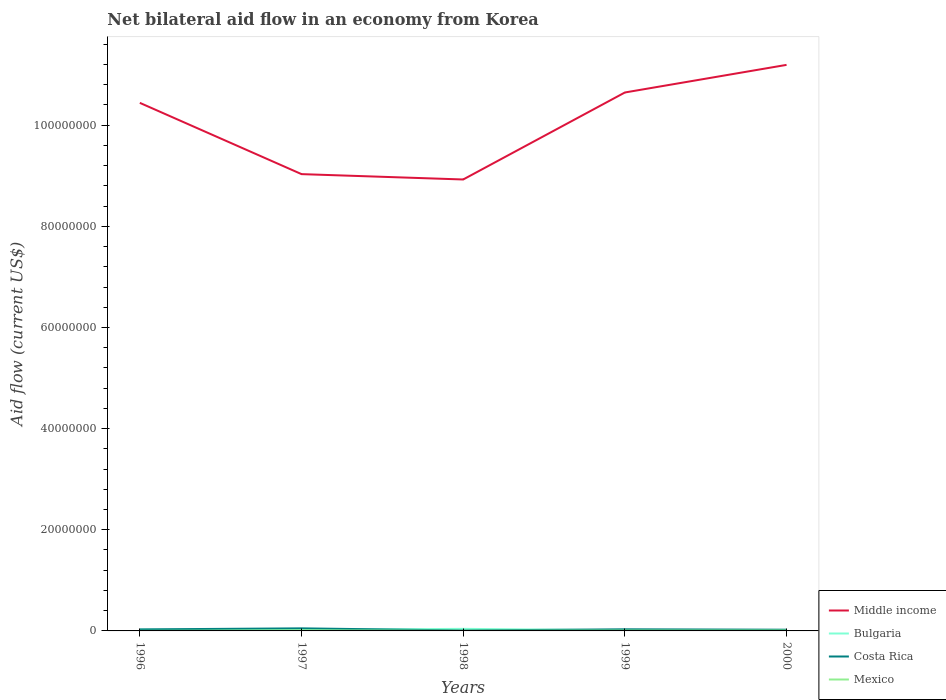How many different coloured lines are there?
Offer a very short reply. 4. Does the line corresponding to Bulgaria intersect with the line corresponding to Mexico?
Offer a terse response. No. Across all years, what is the maximum net bilateral aid flow in Middle income?
Offer a terse response. 8.93e+07. In which year was the net bilateral aid flow in Costa Rica maximum?
Give a very brief answer. 1998. What is the difference between the highest and the second highest net bilateral aid flow in Costa Rica?
Offer a very short reply. 4.20e+05. What is the difference between the highest and the lowest net bilateral aid flow in Bulgaria?
Make the answer very short. 2. Is the net bilateral aid flow in Bulgaria strictly greater than the net bilateral aid flow in Middle income over the years?
Ensure brevity in your answer.  Yes. How many years are there in the graph?
Give a very brief answer. 5. Does the graph contain any zero values?
Your response must be concise. No. How many legend labels are there?
Provide a short and direct response. 4. What is the title of the graph?
Ensure brevity in your answer.  Net bilateral aid flow in an economy from Korea. What is the label or title of the Y-axis?
Give a very brief answer. Aid flow (current US$). What is the Aid flow (current US$) in Middle income in 1996?
Offer a terse response. 1.04e+08. What is the Aid flow (current US$) of Bulgaria in 1996?
Make the answer very short. 2.40e+05. What is the Aid flow (current US$) in Mexico in 1996?
Ensure brevity in your answer.  10000. What is the Aid flow (current US$) of Middle income in 1997?
Your answer should be compact. 9.03e+07. What is the Aid flow (current US$) of Costa Rica in 1997?
Provide a short and direct response. 5.10e+05. What is the Aid flow (current US$) in Middle income in 1998?
Give a very brief answer. 8.93e+07. What is the Aid flow (current US$) of Bulgaria in 1998?
Keep it short and to the point. 4.10e+05. What is the Aid flow (current US$) in Mexico in 1998?
Provide a short and direct response. 3.00e+04. What is the Aid flow (current US$) in Middle income in 1999?
Ensure brevity in your answer.  1.06e+08. What is the Aid flow (current US$) of Bulgaria in 1999?
Offer a terse response. 1.20e+05. What is the Aid flow (current US$) of Mexico in 1999?
Make the answer very short. 7.00e+04. What is the Aid flow (current US$) in Middle income in 2000?
Provide a succinct answer. 1.12e+08. What is the Aid flow (current US$) of Bulgaria in 2000?
Provide a succinct answer. 1.30e+05. What is the Aid flow (current US$) of Costa Rica in 2000?
Offer a very short reply. 2.40e+05. What is the Aid flow (current US$) of Mexico in 2000?
Keep it short and to the point. 8.00e+04. Across all years, what is the maximum Aid flow (current US$) in Middle income?
Ensure brevity in your answer.  1.12e+08. Across all years, what is the maximum Aid flow (current US$) in Bulgaria?
Make the answer very short. 4.10e+05. Across all years, what is the maximum Aid flow (current US$) in Costa Rica?
Ensure brevity in your answer.  5.10e+05. Across all years, what is the maximum Aid flow (current US$) in Mexico?
Offer a very short reply. 1.10e+05. Across all years, what is the minimum Aid flow (current US$) in Middle income?
Make the answer very short. 8.93e+07. Across all years, what is the minimum Aid flow (current US$) in Costa Rica?
Ensure brevity in your answer.  9.00e+04. What is the total Aid flow (current US$) of Middle income in the graph?
Your answer should be very brief. 5.02e+08. What is the total Aid flow (current US$) in Bulgaria in the graph?
Ensure brevity in your answer.  1.10e+06. What is the total Aid flow (current US$) of Costa Rica in the graph?
Offer a very short reply. 1.46e+06. What is the total Aid flow (current US$) of Mexico in the graph?
Your answer should be very brief. 3.00e+05. What is the difference between the Aid flow (current US$) of Middle income in 1996 and that in 1997?
Ensure brevity in your answer.  1.41e+07. What is the difference between the Aid flow (current US$) in Bulgaria in 1996 and that in 1997?
Provide a short and direct response. 4.00e+04. What is the difference between the Aid flow (current US$) in Mexico in 1996 and that in 1997?
Your answer should be compact. -1.00e+05. What is the difference between the Aid flow (current US$) in Middle income in 1996 and that in 1998?
Keep it short and to the point. 1.52e+07. What is the difference between the Aid flow (current US$) in Bulgaria in 1996 and that in 1998?
Provide a succinct answer. -1.70e+05. What is the difference between the Aid flow (current US$) in Costa Rica in 1996 and that in 1998?
Your answer should be compact. 2.10e+05. What is the difference between the Aid flow (current US$) in Mexico in 1996 and that in 1998?
Ensure brevity in your answer.  -2.00e+04. What is the difference between the Aid flow (current US$) of Middle income in 1996 and that in 1999?
Give a very brief answer. -2.05e+06. What is the difference between the Aid flow (current US$) in Bulgaria in 1996 and that in 1999?
Your answer should be compact. 1.20e+05. What is the difference between the Aid flow (current US$) of Costa Rica in 1996 and that in 1999?
Offer a terse response. -2.00e+04. What is the difference between the Aid flow (current US$) in Mexico in 1996 and that in 1999?
Ensure brevity in your answer.  -6.00e+04. What is the difference between the Aid flow (current US$) of Middle income in 1996 and that in 2000?
Offer a very short reply. -7.51e+06. What is the difference between the Aid flow (current US$) of Mexico in 1996 and that in 2000?
Provide a short and direct response. -7.00e+04. What is the difference between the Aid flow (current US$) of Middle income in 1997 and that in 1998?
Provide a succinct answer. 1.06e+06. What is the difference between the Aid flow (current US$) in Bulgaria in 1997 and that in 1998?
Your answer should be very brief. -2.10e+05. What is the difference between the Aid flow (current US$) of Costa Rica in 1997 and that in 1998?
Make the answer very short. 4.20e+05. What is the difference between the Aid flow (current US$) in Mexico in 1997 and that in 1998?
Your response must be concise. 8.00e+04. What is the difference between the Aid flow (current US$) of Middle income in 1997 and that in 1999?
Your response must be concise. -1.61e+07. What is the difference between the Aid flow (current US$) in Bulgaria in 1997 and that in 1999?
Keep it short and to the point. 8.00e+04. What is the difference between the Aid flow (current US$) of Mexico in 1997 and that in 1999?
Keep it short and to the point. 4.00e+04. What is the difference between the Aid flow (current US$) in Middle income in 1997 and that in 2000?
Provide a short and direct response. -2.16e+07. What is the difference between the Aid flow (current US$) of Costa Rica in 1997 and that in 2000?
Provide a short and direct response. 2.70e+05. What is the difference between the Aid flow (current US$) of Middle income in 1998 and that in 1999?
Your answer should be compact. -1.72e+07. What is the difference between the Aid flow (current US$) in Mexico in 1998 and that in 1999?
Provide a short and direct response. -4.00e+04. What is the difference between the Aid flow (current US$) of Middle income in 1998 and that in 2000?
Your answer should be very brief. -2.27e+07. What is the difference between the Aid flow (current US$) in Costa Rica in 1998 and that in 2000?
Offer a terse response. -1.50e+05. What is the difference between the Aid flow (current US$) in Mexico in 1998 and that in 2000?
Offer a terse response. -5.00e+04. What is the difference between the Aid flow (current US$) of Middle income in 1999 and that in 2000?
Offer a terse response. -5.46e+06. What is the difference between the Aid flow (current US$) in Bulgaria in 1999 and that in 2000?
Provide a short and direct response. -10000. What is the difference between the Aid flow (current US$) of Middle income in 1996 and the Aid flow (current US$) of Bulgaria in 1997?
Keep it short and to the point. 1.04e+08. What is the difference between the Aid flow (current US$) of Middle income in 1996 and the Aid flow (current US$) of Costa Rica in 1997?
Offer a very short reply. 1.04e+08. What is the difference between the Aid flow (current US$) of Middle income in 1996 and the Aid flow (current US$) of Mexico in 1997?
Your response must be concise. 1.04e+08. What is the difference between the Aid flow (current US$) of Bulgaria in 1996 and the Aid flow (current US$) of Mexico in 1997?
Your answer should be very brief. 1.30e+05. What is the difference between the Aid flow (current US$) in Middle income in 1996 and the Aid flow (current US$) in Bulgaria in 1998?
Your response must be concise. 1.04e+08. What is the difference between the Aid flow (current US$) in Middle income in 1996 and the Aid flow (current US$) in Costa Rica in 1998?
Your answer should be compact. 1.04e+08. What is the difference between the Aid flow (current US$) of Middle income in 1996 and the Aid flow (current US$) of Mexico in 1998?
Offer a very short reply. 1.04e+08. What is the difference between the Aid flow (current US$) in Bulgaria in 1996 and the Aid flow (current US$) in Costa Rica in 1998?
Make the answer very short. 1.50e+05. What is the difference between the Aid flow (current US$) of Middle income in 1996 and the Aid flow (current US$) of Bulgaria in 1999?
Your answer should be compact. 1.04e+08. What is the difference between the Aid flow (current US$) in Middle income in 1996 and the Aid flow (current US$) in Costa Rica in 1999?
Give a very brief answer. 1.04e+08. What is the difference between the Aid flow (current US$) of Middle income in 1996 and the Aid flow (current US$) of Mexico in 1999?
Provide a succinct answer. 1.04e+08. What is the difference between the Aid flow (current US$) of Bulgaria in 1996 and the Aid flow (current US$) of Costa Rica in 1999?
Offer a very short reply. -8.00e+04. What is the difference between the Aid flow (current US$) of Middle income in 1996 and the Aid flow (current US$) of Bulgaria in 2000?
Give a very brief answer. 1.04e+08. What is the difference between the Aid flow (current US$) of Middle income in 1996 and the Aid flow (current US$) of Costa Rica in 2000?
Your response must be concise. 1.04e+08. What is the difference between the Aid flow (current US$) of Middle income in 1996 and the Aid flow (current US$) of Mexico in 2000?
Your response must be concise. 1.04e+08. What is the difference between the Aid flow (current US$) of Costa Rica in 1996 and the Aid flow (current US$) of Mexico in 2000?
Keep it short and to the point. 2.20e+05. What is the difference between the Aid flow (current US$) in Middle income in 1997 and the Aid flow (current US$) in Bulgaria in 1998?
Ensure brevity in your answer.  8.99e+07. What is the difference between the Aid flow (current US$) in Middle income in 1997 and the Aid flow (current US$) in Costa Rica in 1998?
Your answer should be very brief. 9.02e+07. What is the difference between the Aid flow (current US$) in Middle income in 1997 and the Aid flow (current US$) in Mexico in 1998?
Provide a succinct answer. 9.03e+07. What is the difference between the Aid flow (current US$) of Bulgaria in 1997 and the Aid flow (current US$) of Costa Rica in 1998?
Provide a short and direct response. 1.10e+05. What is the difference between the Aid flow (current US$) in Bulgaria in 1997 and the Aid flow (current US$) in Mexico in 1998?
Provide a succinct answer. 1.70e+05. What is the difference between the Aid flow (current US$) of Costa Rica in 1997 and the Aid flow (current US$) of Mexico in 1998?
Make the answer very short. 4.80e+05. What is the difference between the Aid flow (current US$) in Middle income in 1997 and the Aid flow (current US$) in Bulgaria in 1999?
Provide a short and direct response. 9.02e+07. What is the difference between the Aid flow (current US$) of Middle income in 1997 and the Aid flow (current US$) of Costa Rica in 1999?
Keep it short and to the point. 9.00e+07. What is the difference between the Aid flow (current US$) in Middle income in 1997 and the Aid flow (current US$) in Mexico in 1999?
Keep it short and to the point. 9.02e+07. What is the difference between the Aid flow (current US$) in Costa Rica in 1997 and the Aid flow (current US$) in Mexico in 1999?
Your answer should be very brief. 4.40e+05. What is the difference between the Aid flow (current US$) in Middle income in 1997 and the Aid flow (current US$) in Bulgaria in 2000?
Make the answer very short. 9.02e+07. What is the difference between the Aid flow (current US$) of Middle income in 1997 and the Aid flow (current US$) of Costa Rica in 2000?
Ensure brevity in your answer.  9.01e+07. What is the difference between the Aid flow (current US$) of Middle income in 1997 and the Aid flow (current US$) of Mexico in 2000?
Give a very brief answer. 9.02e+07. What is the difference between the Aid flow (current US$) of Bulgaria in 1997 and the Aid flow (current US$) of Costa Rica in 2000?
Your answer should be very brief. -4.00e+04. What is the difference between the Aid flow (current US$) of Costa Rica in 1997 and the Aid flow (current US$) of Mexico in 2000?
Your response must be concise. 4.30e+05. What is the difference between the Aid flow (current US$) of Middle income in 1998 and the Aid flow (current US$) of Bulgaria in 1999?
Provide a succinct answer. 8.91e+07. What is the difference between the Aid flow (current US$) of Middle income in 1998 and the Aid flow (current US$) of Costa Rica in 1999?
Ensure brevity in your answer.  8.89e+07. What is the difference between the Aid flow (current US$) of Middle income in 1998 and the Aid flow (current US$) of Mexico in 1999?
Offer a very short reply. 8.92e+07. What is the difference between the Aid flow (current US$) in Bulgaria in 1998 and the Aid flow (current US$) in Costa Rica in 1999?
Keep it short and to the point. 9.00e+04. What is the difference between the Aid flow (current US$) of Middle income in 1998 and the Aid flow (current US$) of Bulgaria in 2000?
Keep it short and to the point. 8.91e+07. What is the difference between the Aid flow (current US$) of Middle income in 1998 and the Aid flow (current US$) of Costa Rica in 2000?
Make the answer very short. 8.90e+07. What is the difference between the Aid flow (current US$) in Middle income in 1998 and the Aid flow (current US$) in Mexico in 2000?
Provide a short and direct response. 8.92e+07. What is the difference between the Aid flow (current US$) of Bulgaria in 1998 and the Aid flow (current US$) of Costa Rica in 2000?
Provide a succinct answer. 1.70e+05. What is the difference between the Aid flow (current US$) in Bulgaria in 1998 and the Aid flow (current US$) in Mexico in 2000?
Your answer should be very brief. 3.30e+05. What is the difference between the Aid flow (current US$) in Middle income in 1999 and the Aid flow (current US$) in Bulgaria in 2000?
Give a very brief answer. 1.06e+08. What is the difference between the Aid flow (current US$) in Middle income in 1999 and the Aid flow (current US$) in Costa Rica in 2000?
Ensure brevity in your answer.  1.06e+08. What is the difference between the Aid flow (current US$) in Middle income in 1999 and the Aid flow (current US$) in Mexico in 2000?
Ensure brevity in your answer.  1.06e+08. What is the difference between the Aid flow (current US$) in Bulgaria in 1999 and the Aid flow (current US$) in Costa Rica in 2000?
Provide a short and direct response. -1.20e+05. What is the average Aid flow (current US$) of Middle income per year?
Keep it short and to the point. 1.00e+08. What is the average Aid flow (current US$) in Bulgaria per year?
Give a very brief answer. 2.20e+05. What is the average Aid flow (current US$) of Costa Rica per year?
Keep it short and to the point. 2.92e+05. In the year 1996, what is the difference between the Aid flow (current US$) of Middle income and Aid flow (current US$) of Bulgaria?
Your response must be concise. 1.04e+08. In the year 1996, what is the difference between the Aid flow (current US$) of Middle income and Aid flow (current US$) of Costa Rica?
Provide a short and direct response. 1.04e+08. In the year 1996, what is the difference between the Aid flow (current US$) of Middle income and Aid flow (current US$) of Mexico?
Provide a short and direct response. 1.04e+08. In the year 1997, what is the difference between the Aid flow (current US$) in Middle income and Aid flow (current US$) in Bulgaria?
Ensure brevity in your answer.  9.01e+07. In the year 1997, what is the difference between the Aid flow (current US$) in Middle income and Aid flow (current US$) in Costa Rica?
Offer a terse response. 8.98e+07. In the year 1997, what is the difference between the Aid flow (current US$) in Middle income and Aid flow (current US$) in Mexico?
Make the answer very short. 9.02e+07. In the year 1997, what is the difference between the Aid flow (current US$) in Bulgaria and Aid flow (current US$) in Costa Rica?
Your response must be concise. -3.10e+05. In the year 1998, what is the difference between the Aid flow (current US$) in Middle income and Aid flow (current US$) in Bulgaria?
Provide a succinct answer. 8.88e+07. In the year 1998, what is the difference between the Aid flow (current US$) of Middle income and Aid flow (current US$) of Costa Rica?
Keep it short and to the point. 8.92e+07. In the year 1998, what is the difference between the Aid flow (current US$) of Middle income and Aid flow (current US$) of Mexico?
Give a very brief answer. 8.92e+07. In the year 1998, what is the difference between the Aid flow (current US$) of Bulgaria and Aid flow (current US$) of Costa Rica?
Make the answer very short. 3.20e+05. In the year 1999, what is the difference between the Aid flow (current US$) in Middle income and Aid flow (current US$) in Bulgaria?
Offer a terse response. 1.06e+08. In the year 1999, what is the difference between the Aid flow (current US$) of Middle income and Aid flow (current US$) of Costa Rica?
Keep it short and to the point. 1.06e+08. In the year 1999, what is the difference between the Aid flow (current US$) in Middle income and Aid flow (current US$) in Mexico?
Ensure brevity in your answer.  1.06e+08. In the year 1999, what is the difference between the Aid flow (current US$) of Bulgaria and Aid flow (current US$) of Mexico?
Keep it short and to the point. 5.00e+04. In the year 1999, what is the difference between the Aid flow (current US$) of Costa Rica and Aid flow (current US$) of Mexico?
Provide a short and direct response. 2.50e+05. In the year 2000, what is the difference between the Aid flow (current US$) of Middle income and Aid flow (current US$) of Bulgaria?
Your response must be concise. 1.12e+08. In the year 2000, what is the difference between the Aid flow (current US$) of Middle income and Aid flow (current US$) of Costa Rica?
Your answer should be very brief. 1.12e+08. In the year 2000, what is the difference between the Aid flow (current US$) in Middle income and Aid flow (current US$) in Mexico?
Provide a succinct answer. 1.12e+08. In the year 2000, what is the difference between the Aid flow (current US$) in Bulgaria and Aid flow (current US$) in Costa Rica?
Offer a very short reply. -1.10e+05. In the year 2000, what is the difference between the Aid flow (current US$) of Bulgaria and Aid flow (current US$) of Mexico?
Offer a terse response. 5.00e+04. In the year 2000, what is the difference between the Aid flow (current US$) of Costa Rica and Aid flow (current US$) of Mexico?
Your answer should be compact. 1.60e+05. What is the ratio of the Aid flow (current US$) in Middle income in 1996 to that in 1997?
Your answer should be compact. 1.16. What is the ratio of the Aid flow (current US$) in Costa Rica in 1996 to that in 1997?
Make the answer very short. 0.59. What is the ratio of the Aid flow (current US$) in Mexico in 1996 to that in 1997?
Keep it short and to the point. 0.09. What is the ratio of the Aid flow (current US$) of Middle income in 1996 to that in 1998?
Keep it short and to the point. 1.17. What is the ratio of the Aid flow (current US$) in Bulgaria in 1996 to that in 1998?
Provide a succinct answer. 0.59. What is the ratio of the Aid flow (current US$) of Middle income in 1996 to that in 1999?
Your answer should be very brief. 0.98. What is the ratio of the Aid flow (current US$) of Bulgaria in 1996 to that in 1999?
Your response must be concise. 2. What is the ratio of the Aid flow (current US$) in Mexico in 1996 to that in 1999?
Ensure brevity in your answer.  0.14. What is the ratio of the Aid flow (current US$) in Middle income in 1996 to that in 2000?
Provide a succinct answer. 0.93. What is the ratio of the Aid flow (current US$) of Bulgaria in 1996 to that in 2000?
Your answer should be compact. 1.85. What is the ratio of the Aid flow (current US$) in Costa Rica in 1996 to that in 2000?
Your answer should be very brief. 1.25. What is the ratio of the Aid flow (current US$) of Middle income in 1997 to that in 1998?
Offer a very short reply. 1.01. What is the ratio of the Aid flow (current US$) in Bulgaria in 1997 to that in 1998?
Offer a very short reply. 0.49. What is the ratio of the Aid flow (current US$) in Costa Rica in 1997 to that in 1998?
Offer a terse response. 5.67. What is the ratio of the Aid flow (current US$) in Mexico in 1997 to that in 1998?
Your response must be concise. 3.67. What is the ratio of the Aid flow (current US$) in Middle income in 1997 to that in 1999?
Provide a succinct answer. 0.85. What is the ratio of the Aid flow (current US$) of Costa Rica in 1997 to that in 1999?
Give a very brief answer. 1.59. What is the ratio of the Aid flow (current US$) of Mexico in 1997 to that in 1999?
Provide a short and direct response. 1.57. What is the ratio of the Aid flow (current US$) of Middle income in 1997 to that in 2000?
Give a very brief answer. 0.81. What is the ratio of the Aid flow (current US$) of Bulgaria in 1997 to that in 2000?
Make the answer very short. 1.54. What is the ratio of the Aid flow (current US$) in Costa Rica in 1997 to that in 2000?
Your response must be concise. 2.12. What is the ratio of the Aid flow (current US$) in Mexico in 1997 to that in 2000?
Your response must be concise. 1.38. What is the ratio of the Aid flow (current US$) of Middle income in 1998 to that in 1999?
Your answer should be compact. 0.84. What is the ratio of the Aid flow (current US$) of Bulgaria in 1998 to that in 1999?
Provide a short and direct response. 3.42. What is the ratio of the Aid flow (current US$) in Costa Rica in 1998 to that in 1999?
Offer a terse response. 0.28. What is the ratio of the Aid flow (current US$) in Mexico in 1998 to that in 1999?
Provide a short and direct response. 0.43. What is the ratio of the Aid flow (current US$) of Middle income in 1998 to that in 2000?
Provide a succinct answer. 0.8. What is the ratio of the Aid flow (current US$) of Bulgaria in 1998 to that in 2000?
Your answer should be very brief. 3.15. What is the ratio of the Aid flow (current US$) in Mexico in 1998 to that in 2000?
Offer a terse response. 0.38. What is the ratio of the Aid flow (current US$) of Middle income in 1999 to that in 2000?
Provide a short and direct response. 0.95. What is the ratio of the Aid flow (current US$) in Costa Rica in 1999 to that in 2000?
Make the answer very short. 1.33. What is the difference between the highest and the second highest Aid flow (current US$) in Middle income?
Provide a short and direct response. 5.46e+06. What is the difference between the highest and the lowest Aid flow (current US$) in Middle income?
Provide a short and direct response. 2.27e+07. What is the difference between the highest and the lowest Aid flow (current US$) in Bulgaria?
Your answer should be compact. 2.90e+05. 